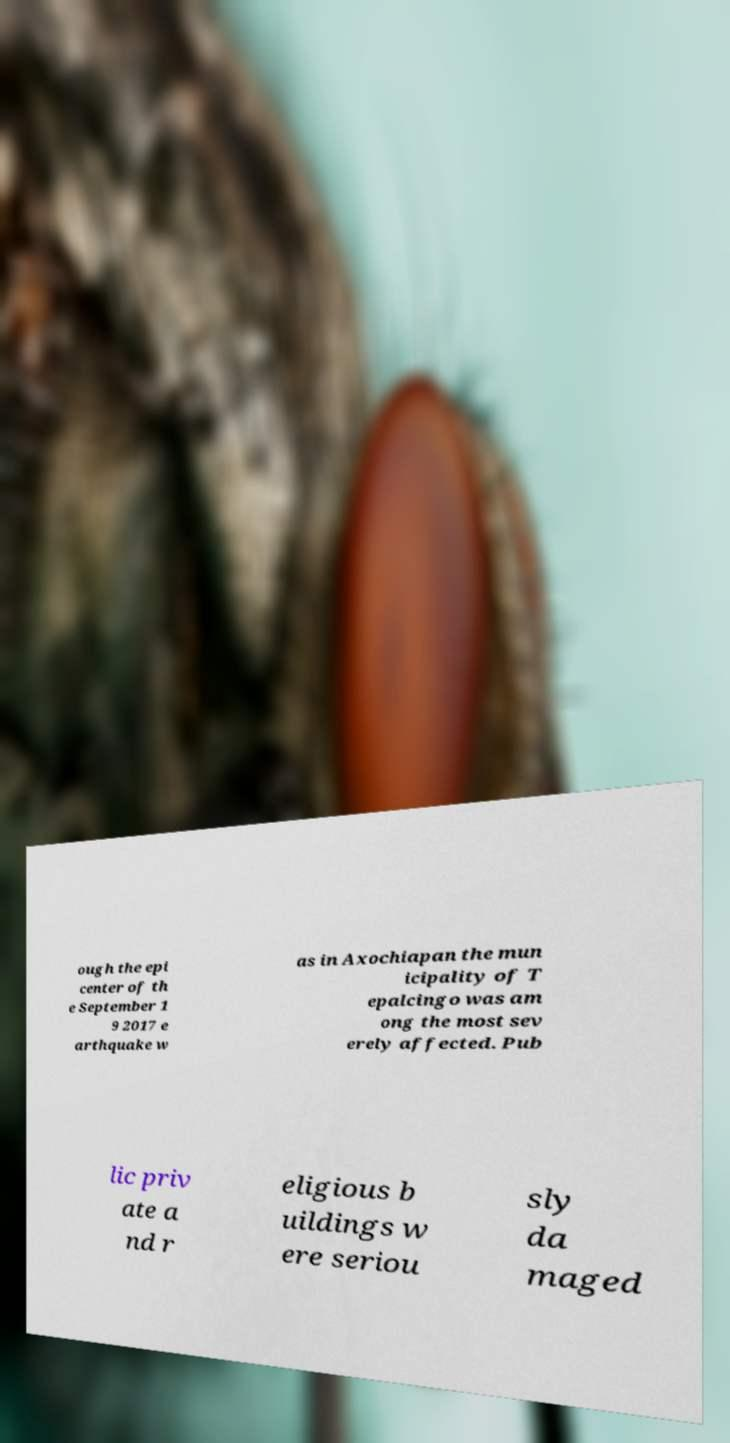For documentation purposes, I need the text within this image transcribed. Could you provide that? ough the epi center of th e September 1 9 2017 e arthquake w as in Axochiapan the mun icipality of T epalcingo was am ong the most sev erely affected. Pub lic priv ate a nd r eligious b uildings w ere seriou sly da maged 